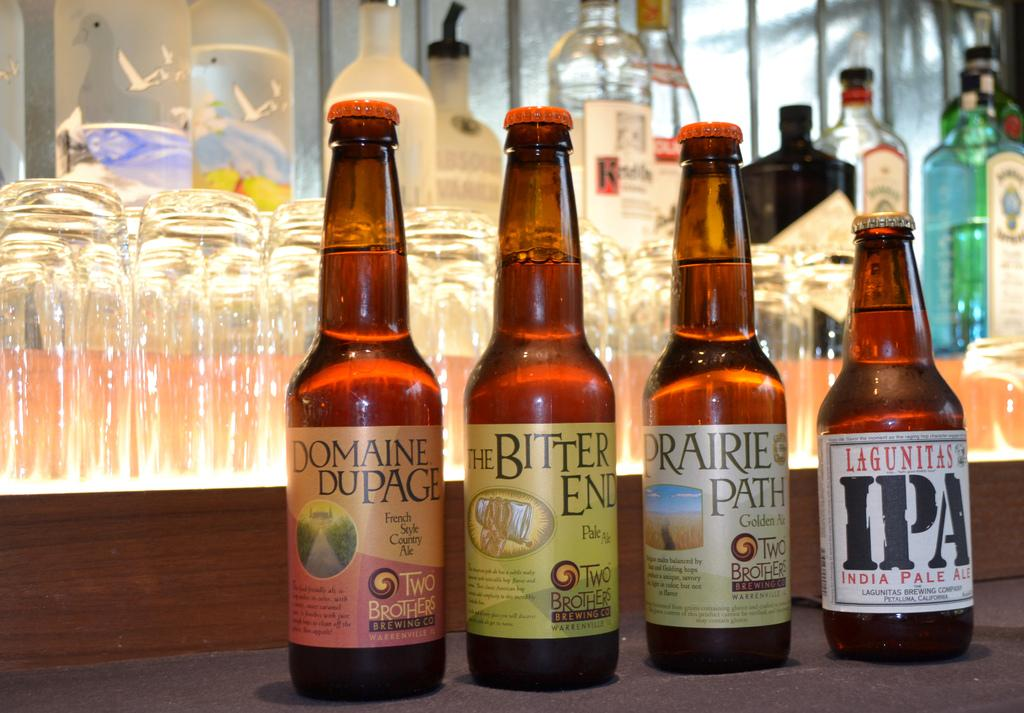What type of containers can be seen in the image? There are bottles and glasses in the image. Can you describe the contents of the containers? The provided facts do not specify the contents of the containers. What type of treatment is the father receiving in the garden in the image? There is no father or garden present in the image; it only features bottles and glasses. 